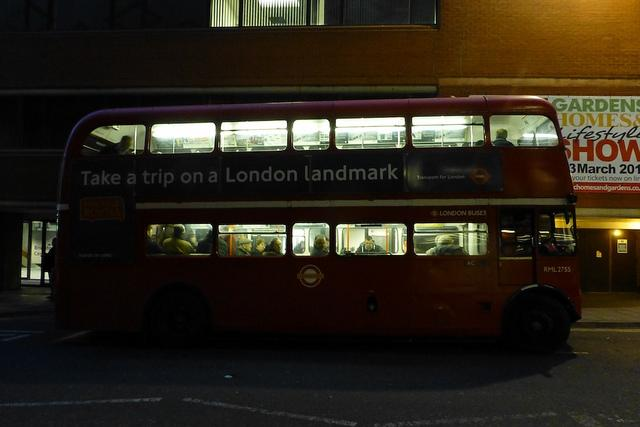Why is the light on inside the double-decker bus?

Choices:
A) visibility
B) convenience
C) aesthetics
D) by law visibility 